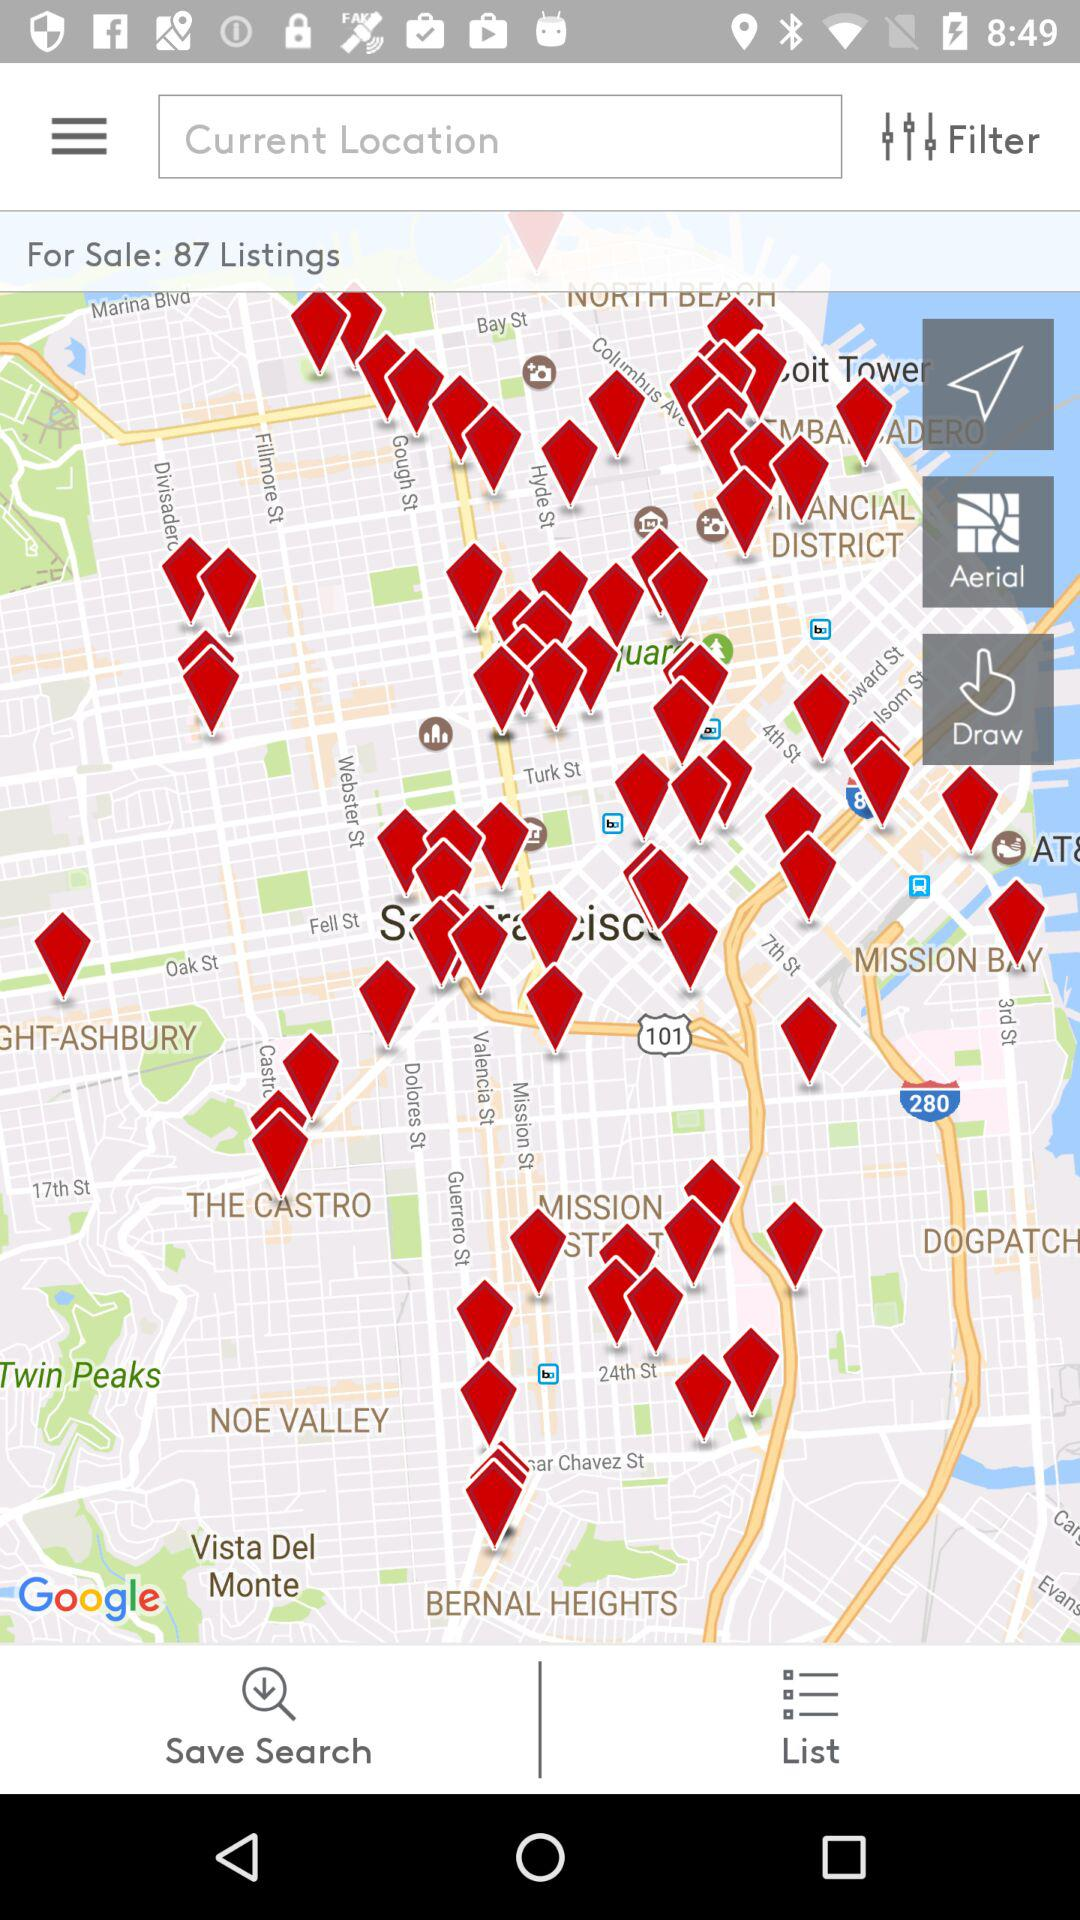What is the number of listings for sale? The number of listings for sale is 87. 